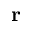<formula> <loc_0><loc_0><loc_500><loc_500>r</formula> 